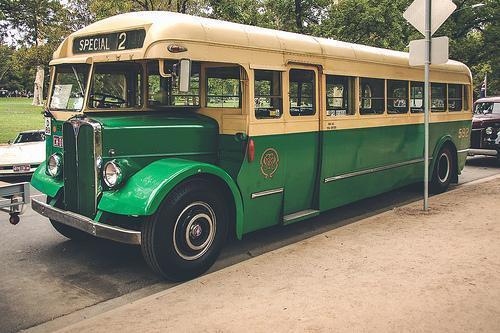How many buses are visible?
Give a very brief answer. 1. 